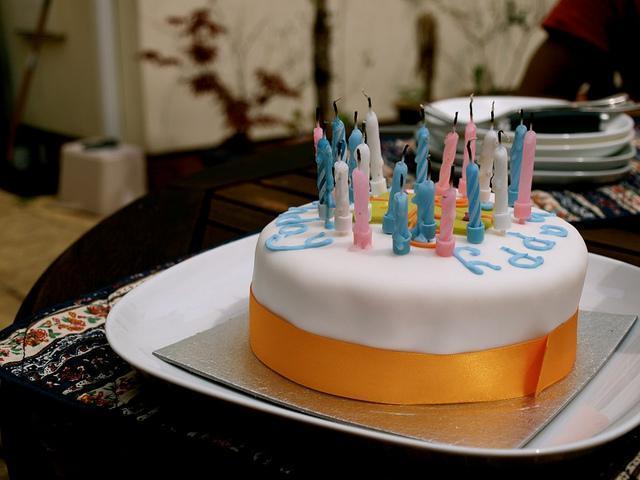How many cakes are in the photo?
Give a very brief answer. 1. 